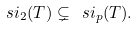<formula> <loc_0><loc_0><loc_500><loc_500>\ s i _ { 2 } ( T ) \subsetneq \ s i _ { p } ( T ) .</formula> 